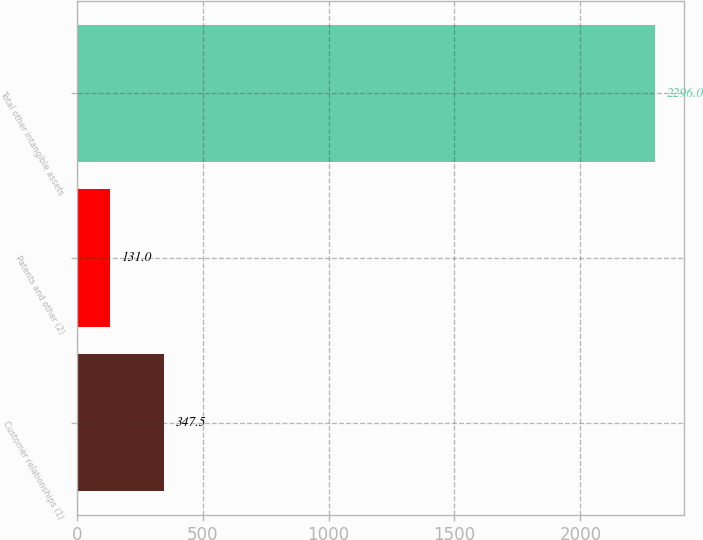Convert chart. <chart><loc_0><loc_0><loc_500><loc_500><bar_chart><fcel>Customer relationships (1)<fcel>Patents and other (2)<fcel>Total other intangible assets<nl><fcel>347.5<fcel>131<fcel>2296<nl></chart> 